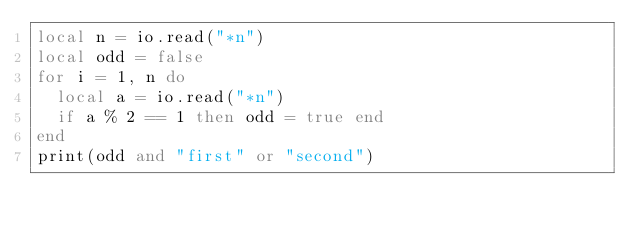<code> <loc_0><loc_0><loc_500><loc_500><_Lua_>local n = io.read("*n")
local odd = false
for i = 1, n do
  local a = io.read("*n")
  if a % 2 == 1 then odd = true end
end
print(odd and "first" or "second")
</code> 